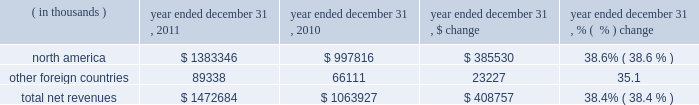2022 selling costs increased $ 25.0 million to $ 94.6 million in 2010 from $ 69.6 million in 2009 .
This increase was primarily due to higher personnel and other costs incurred for the continued expansion of our direct to consumer distribution channel and higher selling personnel costs , including increased expenses for our performance incentive plan as compared to the prior year .
As a percentage of net revenues , selling costs increased to 8.9% ( 8.9 % ) in 2010 from 8.1% ( 8.1 % ) in 2009 primarily due to higher personnel and other costs incurred for the continued expansion of our factory house stores .
2022 product innovation and supply chain costs increased $ 25.0 million to $ 96.8 million in 2010 from $ 71.8 million in 2009 primarily due to higher personnel costs for the design and sourcing of our expanding apparel , footwear and accessories lines and higher distribution facilities operating and personnel costs as compared to the prior year to support our growth in net revenues .
In addition , we incurred higher expenses for our performance incentive plan as compared to the prior year .
As a percentage of net revenues , product innovation and supply chain costs increased to 9.1% ( 9.1 % ) in 2010 from 8.4% ( 8.4 % ) in 2009 primarily due to the items noted above .
2022 corporate services costs increased $ 24.0 million to $ 98.6 million in 2010 from $ 74.6 million in 2009 .
This increase was attributable primarily to higher corporate facility costs , information technology initiatives and corporate personnel costs , including increased expenses for our performance incentive plan as compared to the prior year .
As a percentage of net revenues , corporate services costs increased to 9.3% ( 9.3 % ) in 2010 from 8.7% ( 8.7 % ) in 2009 primarily due to the items noted above .
Income from operations increased $ 27.1 million , or 31.8% ( 31.8 % ) , to $ 112.4 million in 2010 from $ 85.3 million in 2009 .
Income from operations as a percentage of net revenues increased to 10.6% ( 10.6 % ) in 2010 from 10.0% ( 10.0 % ) in 2009 .
This increase was a result of the items discussed above .
Interest expense , net remained unchanged at $ 2.3 million in 2010 and 2009 .
Other expense , net increased $ 0.7 million to $ 1.2 million in 2010 from $ 0.5 million in 2009 .
The increase in 2010 was due to higher net losses on the combined foreign currency exchange rate changes on transactions denominated in the euro and canadian dollar and our derivative financial instruments as compared to 2009 .
Provision for income taxes increased $ 4.8 million to $ 40.4 million in 2010 from $ 35.6 million in 2009 .
Our effective tax rate was 37.1% ( 37.1 % ) in 2010 compared to 43.2% ( 43.2 % ) in 2009 , primarily due to tax planning strategies and federal and state tax credits reducing the effective tax rate , partially offset by a valuation allowance recorded against our foreign net operating loss carryforward .
Segment results of operations year ended december 31 , 2011 compared to year ended december 31 , 2010 net revenues by geographic region are summarized below: .
Net revenues in our north american operating segment increased $ 385.5 million to $ 1383.3 million in 2011 from $ 997.8 million in 2010 primarily due to the items discussed above in the consolidated results of operations .
Net revenues in other foreign countries increased by $ 23.2 million to $ 89.3 million in 2011 from $ 66.1 million in 2010 primarily due to footwear shipments to our dome licensee , as well as unit sales growth to our distributors in our latin american operating segment. .
What was the percentage increase in the provision for income taxes from 2009 to 2010? 
Rationale: the percentage increase in the provision for income taxes from 2009 to 2010 was 13.5%
Computations: (4.8 / 35.6)
Answer: 0.13483. 